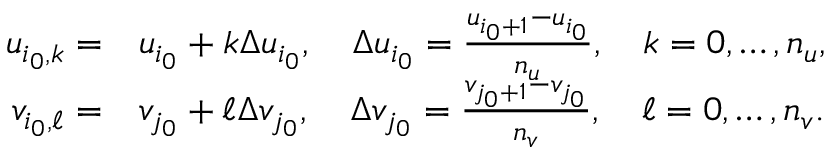<formula> <loc_0><loc_0><loc_500><loc_500>\begin{array} { r l } { u _ { i _ { 0 } , k } = } & u _ { i _ { 0 } } + k \Delta u _ { i _ { 0 } } , \quad \Delta u _ { i _ { 0 } } = \frac { u _ { i _ { 0 } + 1 } - u _ { i _ { 0 } } } { n _ { u } } , \quad k = 0 , \dots , n _ { u } , } \\ { v _ { i _ { 0 } , \ell } = } & v _ { j _ { 0 } } + \ell \Delta v _ { j _ { 0 } } , \quad \Delta v _ { j _ { 0 } } = \frac { v _ { j _ { 0 } + 1 } - v _ { j _ { 0 } } } { n _ { v } } , \quad \ell = 0 , \dots , n _ { v } . } \end{array}</formula> 